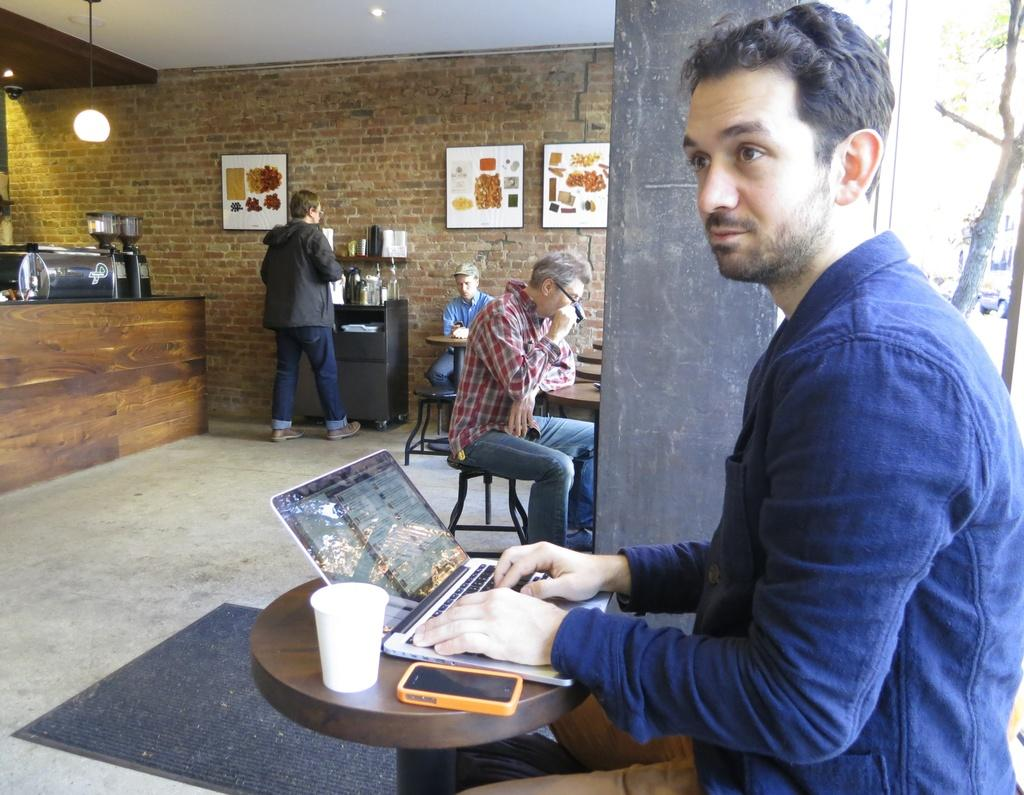What is the man in the image doing? The man is seated and working on a laptop. Where is the man located? The man is in a coffee shop. What are some of the activities happening in the coffee shop? There are people seated drinking coffee. Are there any other people in the coffee shop besides the man working on the laptop? Yes, there is a man standing in the coffee shop. What type of credit can be seen on the man's nails in the image? There is no mention of credit or nails in the image; the man is working on a laptop in a coffee shop. 